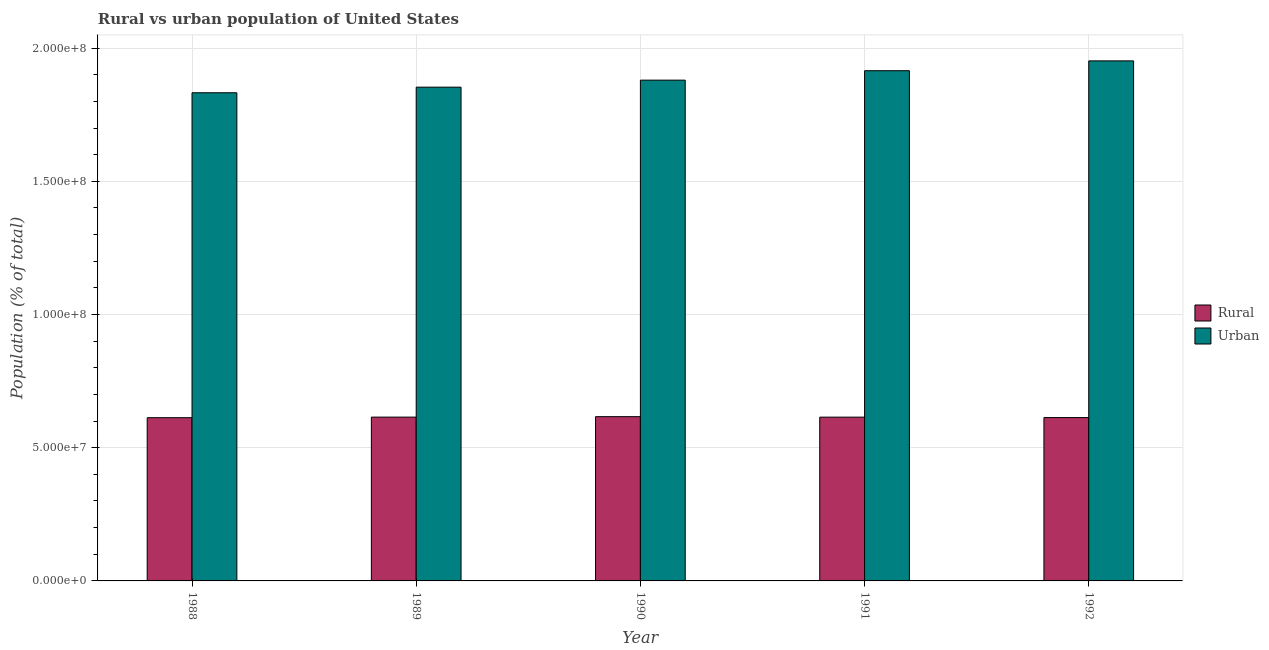Are the number of bars on each tick of the X-axis equal?
Your answer should be compact. Yes. How many bars are there on the 2nd tick from the left?
Provide a succinct answer. 2. What is the rural population density in 1992?
Offer a terse response. 6.13e+07. Across all years, what is the maximum rural population density?
Give a very brief answer. 6.17e+07. Across all years, what is the minimum urban population density?
Your answer should be very brief. 1.83e+08. In which year was the urban population density maximum?
Offer a very short reply. 1992. In which year was the rural population density minimum?
Make the answer very short. 1988. What is the total urban population density in the graph?
Your response must be concise. 9.43e+08. What is the difference between the urban population density in 1989 and that in 1990?
Provide a succinct answer. -2.63e+06. What is the difference between the urban population density in 1992 and the rural population density in 1988?
Give a very brief answer. 1.20e+07. What is the average urban population density per year?
Your answer should be very brief. 1.89e+08. What is the ratio of the rural population density in 1990 to that in 1991?
Provide a short and direct response. 1. Is the urban population density in 1988 less than that in 1989?
Your answer should be compact. Yes. What is the difference between the highest and the second highest rural population density?
Your response must be concise. 1.72e+05. What is the difference between the highest and the lowest rural population density?
Keep it short and to the point. 3.90e+05. What does the 1st bar from the left in 1992 represents?
Keep it short and to the point. Rural. What does the 1st bar from the right in 1988 represents?
Your answer should be very brief. Urban. How many bars are there?
Your answer should be very brief. 10. Are all the bars in the graph horizontal?
Provide a succinct answer. No. How many years are there in the graph?
Your response must be concise. 5. Are the values on the major ticks of Y-axis written in scientific E-notation?
Make the answer very short. Yes. Does the graph contain grids?
Your response must be concise. Yes. What is the title of the graph?
Your answer should be very brief. Rural vs urban population of United States. Does "Residents" appear as one of the legend labels in the graph?
Ensure brevity in your answer.  No. What is the label or title of the X-axis?
Your answer should be very brief. Year. What is the label or title of the Y-axis?
Provide a succinct answer. Population (% of total). What is the Population (% of total) in Rural in 1988?
Provide a short and direct response. 6.13e+07. What is the Population (% of total) in Urban in 1988?
Offer a terse response. 1.83e+08. What is the Population (% of total) of Rural in 1989?
Ensure brevity in your answer.  6.15e+07. What is the Population (% of total) in Urban in 1989?
Ensure brevity in your answer.  1.85e+08. What is the Population (% of total) of Rural in 1990?
Provide a short and direct response. 6.17e+07. What is the Population (% of total) in Urban in 1990?
Make the answer very short. 1.88e+08. What is the Population (% of total) of Rural in 1991?
Your answer should be very brief. 6.15e+07. What is the Population (% of total) in Urban in 1991?
Your response must be concise. 1.92e+08. What is the Population (% of total) of Rural in 1992?
Offer a very short reply. 6.13e+07. What is the Population (% of total) in Urban in 1992?
Give a very brief answer. 1.95e+08. Across all years, what is the maximum Population (% of total) in Rural?
Give a very brief answer. 6.17e+07. Across all years, what is the maximum Population (% of total) of Urban?
Offer a terse response. 1.95e+08. Across all years, what is the minimum Population (% of total) of Rural?
Ensure brevity in your answer.  6.13e+07. Across all years, what is the minimum Population (% of total) of Urban?
Your answer should be very brief. 1.83e+08. What is the total Population (% of total) of Rural in the graph?
Offer a very short reply. 3.07e+08. What is the total Population (% of total) in Urban in the graph?
Your answer should be very brief. 9.43e+08. What is the difference between the Population (% of total) of Rural in 1988 and that in 1989?
Make the answer very short. -2.19e+05. What is the difference between the Population (% of total) in Urban in 1988 and that in 1989?
Your response must be concise. -2.10e+06. What is the difference between the Population (% of total) of Rural in 1988 and that in 1990?
Your answer should be very brief. -3.90e+05. What is the difference between the Population (% of total) of Urban in 1988 and that in 1990?
Provide a short and direct response. -4.73e+06. What is the difference between the Population (% of total) in Rural in 1988 and that in 1991?
Give a very brief answer. -2.05e+05. What is the difference between the Population (% of total) of Urban in 1988 and that in 1991?
Keep it short and to the point. -8.28e+06. What is the difference between the Population (% of total) of Rural in 1988 and that in 1992?
Make the answer very short. -4.80e+04. What is the difference between the Population (% of total) of Urban in 1988 and that in 1992?
Your response must be concise. -1.20e+07. What is the difference between the Population (% of total) in Rural in 1989 and that in 1990?
Your answer should be very brief. -1.72e+05. What is the difference between the Population (% of total) of Urban in 1989 and that in 1990?
Your response must be concise. -2.63e+06. What is the difference between the Population (% of total) in Rural in 1989 and that in 1991?
Ensure brevity in your answer.  1.32e+04. What is the difference between the Population (% of total) in Urban in 1989 and that in 1991?
Give a very brief answer. -6.18e+06. What is the difference between the Population (% of total) in Rural in 1989 and that in 1992?
Your answer should be very brief. 1.71e+05. What is the difference between the Population (% of total) of Urban in 1989 and that in 1992?
Your answer should be very brief. -9.87e+06. What is the difference between the Population (% of total) of Rural in 1990 and that in 1991?
Your answer should be very brief. 1.85e+05. What is the difference between the Population (% of total) in Urban in 1990 and that in 1991?
Make the answer very short. -3.54e+06. What is the difference between the Population (% of total) in Rural in 1990 and that in 1992?
Your answer should be compact. 3.42e+05. What is the difference between the Population (% of total) in Urban in 1990 and that in 1992?
Your answer should be very brief. -7.23e+06. What is the difference between the Population (% of total) of Rural in 1991 and that in 1992?
Provide a succinct answer. 1.57e+05. What is the difference between the Population (% of total) in Urban in 1991 and that in 1992?
Provide a short and direct response. -3.69e+06. What is the difference between the Population (% of total) in Rural in 1988 and the Population (% of total) in Urban in 1989?
Provide a succinct answer. -1.24e+08. What is the difference between the Population (% of total) in Rural in 1988 and the Population (% of total) in Urban in 1990?
Give a very brief answer. -1.27e+08. What is the difference between the Population (% of total) in Rural in 1988 and the Population (% of total) in Urban in 1991?
Ensure brevity in your answer.  -1.30e+08. What is the difference between the Population (% of total) of Rural in 1988 and the Population (% of total) of Urban in 1992?
Provide a succinct answer. -1.34e+08. What is the difference between the Population (% of total) of Rural in 1989 and the Population (% of total) of Urban in 1990?
Give a very brief answer. -1.26e+08. What is the difference between the Population (% of total) of Rural in 1989 and the Population (% of total) of Urban in 1991?
Make the answer very short. -1.30e+08. What is the difference between the Population (% of total) of Rural in 1989 and the Population (% of total) of Urban in 1992?
Make the answer very short. -1.34e+08. What is the difference between the Population (% of total) in Rural in 1990 and the Population (% of total) in Urban in 1991?
Offer a terse response. -1.30e+08. What is the difference between the Population (% of total) of Rural in 1990 and the Population (% of total) of Urban in 1992?
Make the answer very short. -1.34e+08. What is the difference between the Population (% of total) of Rural in 1991 and the Population (% of total) of Urban in 1992?
Your answer should be very brief. -1.34e+08. What is the average Population (% of total) of Rural per year?
Make the answer very short. 6.14e+07. What is the average Population (% of total) of Urban per year?
Offer a terse response. 1.89e+08. In the year 1988, what is the difference between the Population (% of total) in Rural and Population (% of total) in Urban?
Offer a very short reply. -1.22e+08. In the year 1989, what is the difference between the Population (% of total) in Rural and Population (% of total) in Urban?
Make the answer very short. -1.24e+08. In the year 1990, what is the difference between the Population (% of total) of Rural and Population (% of total) of Urban?
Provide a short and direct response. -1.26e+08. In the year 1991, what is the difference between the Population (% of total) of Rural and Population (% of total) of Urban?
Offer a terse response. -1.30e+08. In the year 1992, what is the difference between the Population (% of total) of Rural and Population (% of total) of Urban?
Offer a terse response. -1.34e+08. What is the ratio of the Population (% of total) in Rural in 1988 to that in 1989?
Make the answer very short. 1. What is the ratio of the Population (% of total) of Urban in 1988 to that in 1989?
Your answer should be very brief. 0.99. What is the ratio of the Population (% of total) in Rural in 1988 to that in 1990?
Your answer should be very brief. 0.99. What is the ratio of the Population (% of total) in Urban in 1988 to that in 1990?
Offer a terse response. 0.97. What is the ratio of the Population (% of total) of Urban in 1988 to that in 1991?
Offer a very short reply. 0.96. What is the ratio of the Population (% of total) in Rural in 1988 to that in 1992?
Your answer should be compact. 1. What is the ratio of the Population (% of total) in Urban in 1988 to that in 1992?
Provide a short and direct response. 0.94. What is the ratio of the Population (% of total) of Rural in 1989 to that in 1990?
Provide a succinct answer. 1. What is the ratio of the Population (% of total) in Urban in 1989 to that in 1990?
Provide a short and direct response. 0.99. What is the ratio of the Population (% of total) of Rural in 1989 to that in 1991?
Offer a very short reply. 1. What is the ratio of the Population (% of total) of Urban in 1989 to that in 1991?
Your response must be concise. 0.97. What is the ratio of the Population (% of total) of Rural in 1989 to that in 1992?
Ensure brevity in your answer.  1. What is the ratio of the Population (% of total) in Urban in 1989 to that in 1992?
Provide a succinct answer. 0.95. What is the ratio of the Population (% of total) in Urban in 1990 to that in 1991?
Keep it short and to the point. 0.98. What is the ratio of the Population (% of total) of Rural in 1990 to that in 1992?
Your answer should be compact. 1.01. What is the ratio of the Population (% of total) in Urban in 1990 to that in 1992?
Keep it short and to the point. 0.96. What is the ratio of the Population (% of total) in Rural in 1991 to that in 1992?
Your answer should be compact. 1. What is the ratio of the Population (% of total) of Urban in 1991 to that in 1992?
Offer a terse response. 0.98. What is the difference between the highest and the second highest Population (% of total) in Rural?
Your answer should be very brief. 1.72e+05. What is the difference between the highest and the second highest Population (% of total) of Urban?
Give a very brief answer. 3.69e+06. What is the difference between the highest and the lowest Population (% of total) of Rural?
Make the answer very short. 3.90e+05. What is the difference between the highest and the lowest Population (% of total) in Urban?
Provide a short and direct response. 1.20e+07. 